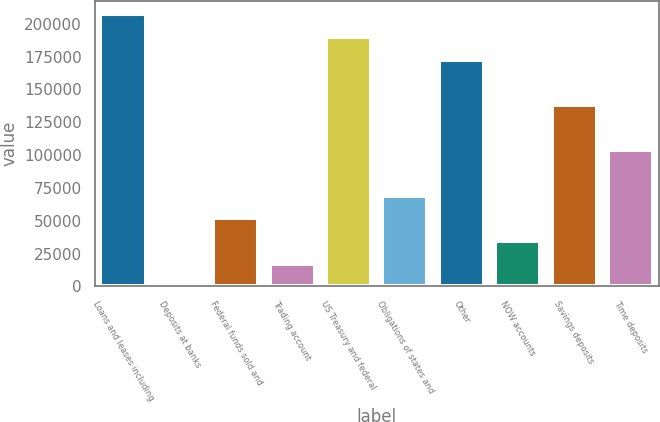<chart> <loc_0><loc_0><loc_500><loc_500><bar_chart><fcel>Loans and leases including<fcel>Deposits at banks<fcel>Federal funds sold and<fcel>Trading account<fcel>US Treasury and federal<fcel>Obligations of states and<fcel>Other<fcel>NOW accounts<fcel>Savings deposits<fcel>Time deposits<nl><fcel>207303<fcel>15<fcel>51837<fcel>17289<fcel>190029<fcel>69111<fcel>172755<fcel>34563<fcel>138207<fcel>103659<nl></chart> 